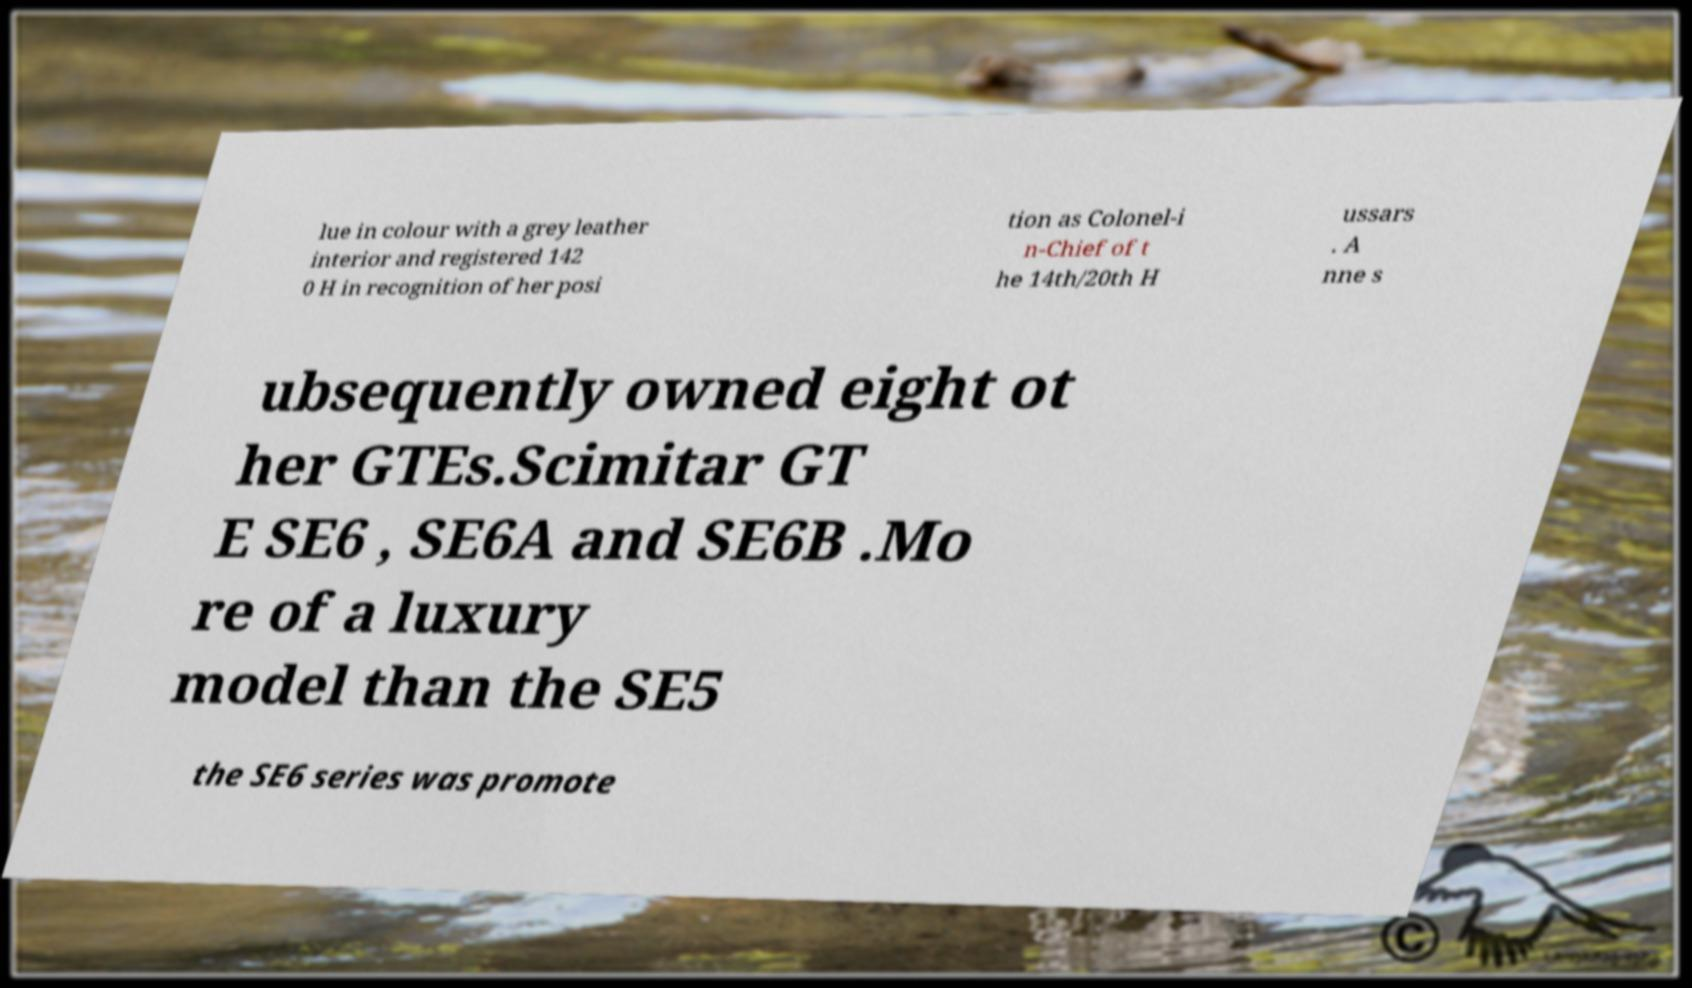Please read and relay the text visible in this image. What does it say? lue in colour with a grey leather interior and registered 142 0 H in recognition of her posi tion as Colonel-i n-Chief of t he 14th/20th H ussars . A nne s ubsequently owned eight ot her GTEs.Scimitar GT E SE6 , SE6A and SE6B .Mo re of a luxury model than the SE5 the SE6 series was promote 